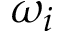<formula> <loc_0><loc_0><loc_500><loc_500>\omega _ { i }</formula> 